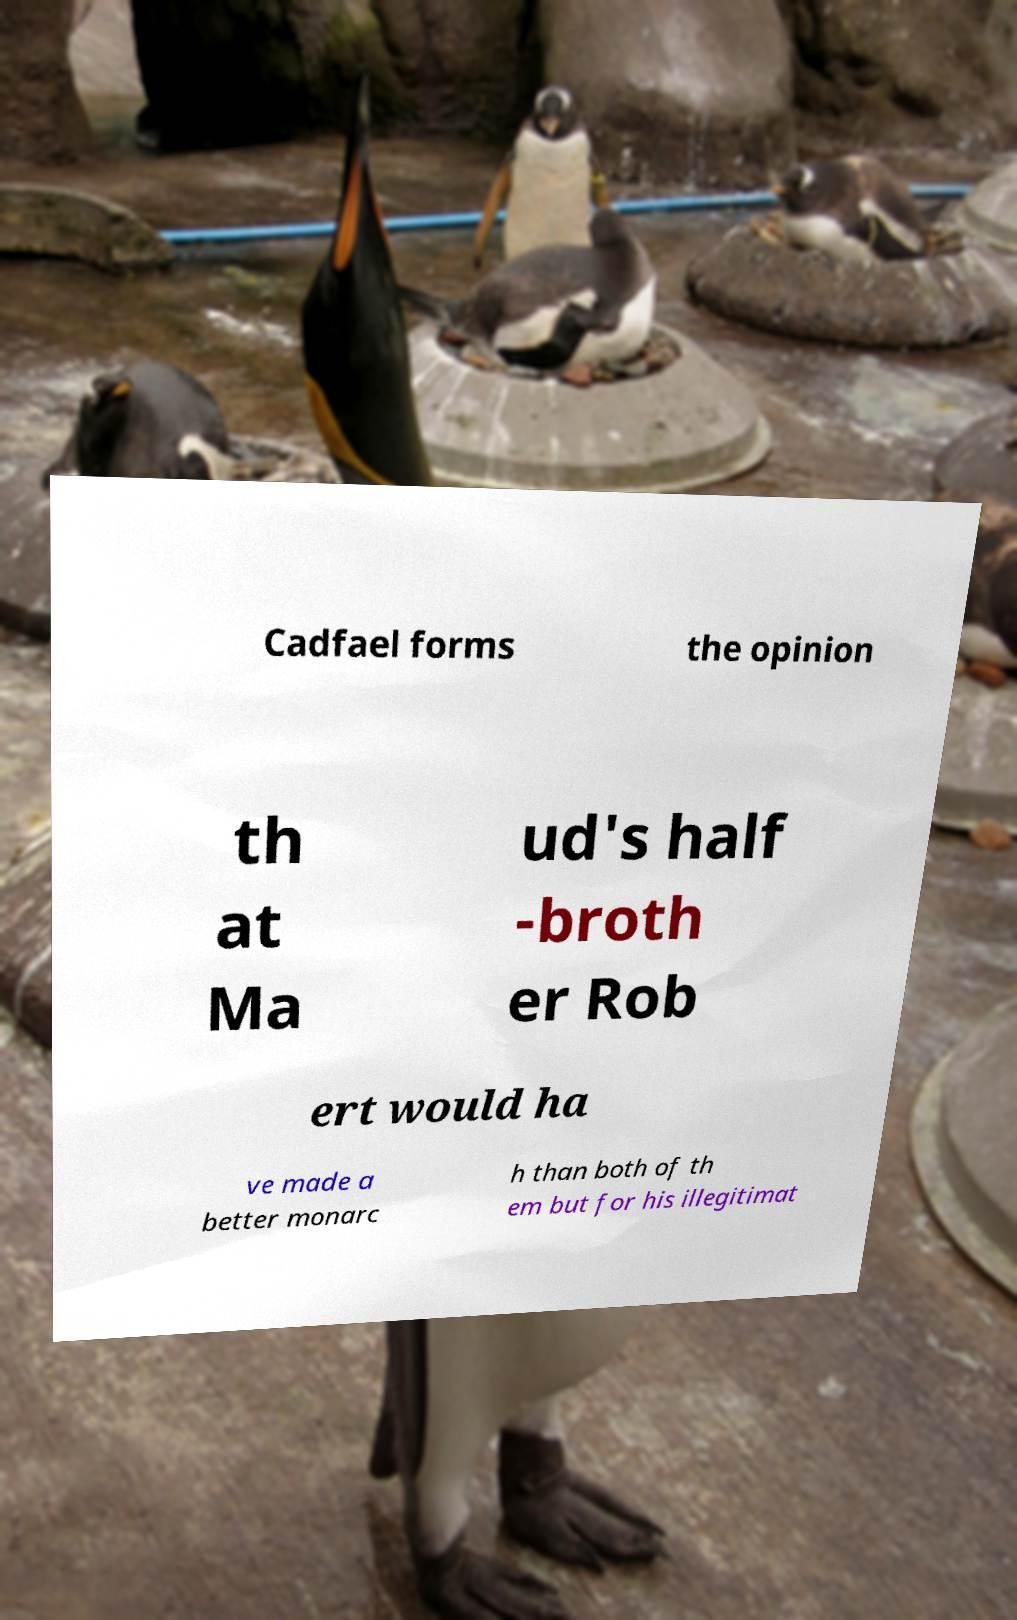What messages or text are displayed in this image? I need them in a readable, typed format. Cadfael forms the opinion th at Ma ud's half -broth er Rob ert would ha ve made a better monarc h than both of th em but for his illegitimat 